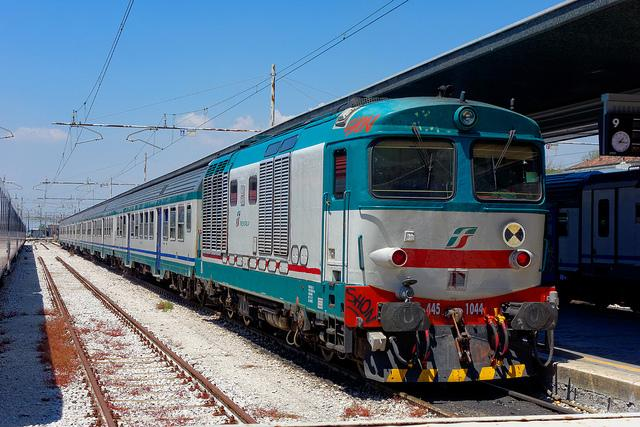What does this train carry? people 